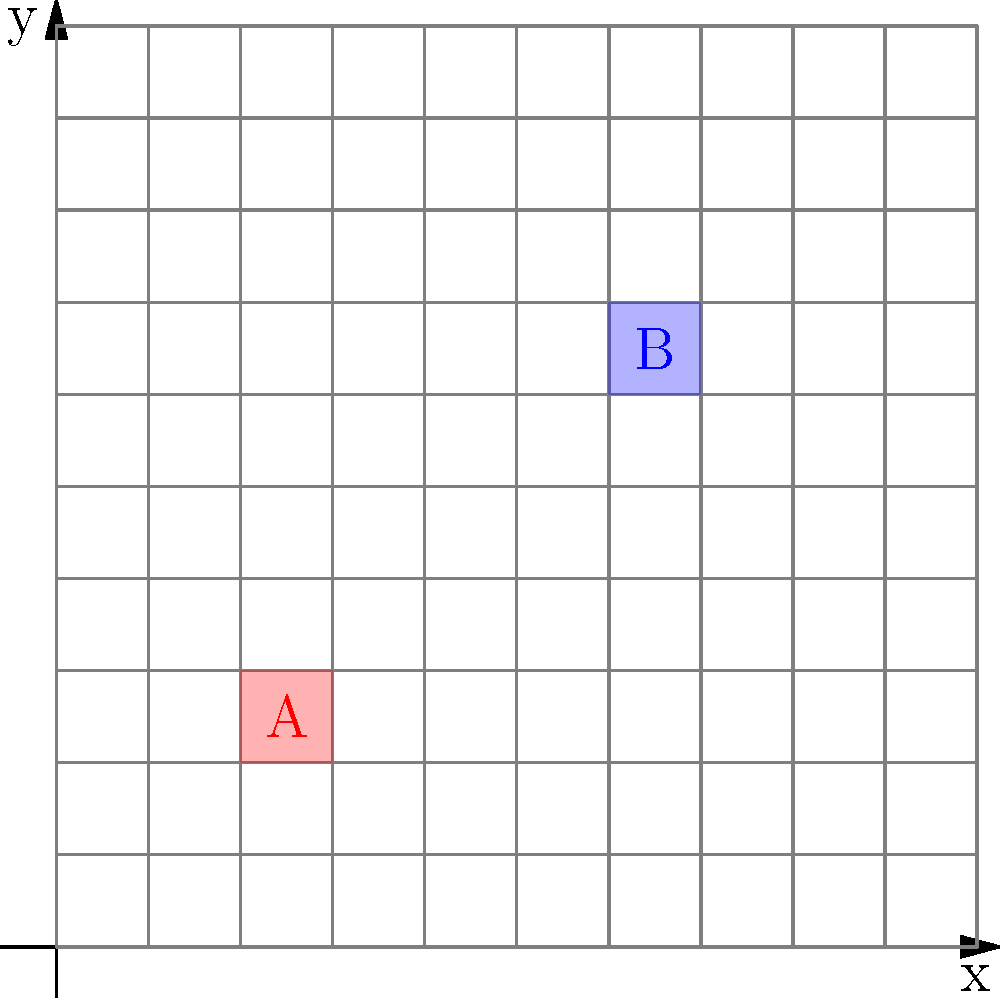In a medical imaging system, a grid pattern is used to assess spatial resolution. The image shows two highlighted squares, A and B, on the grid. If each grid square represents 1 mm, and the smallest discernible feature size is represented by square A, what is the spatial resolution of this imaging system in line pairs per millimeter (lp/mm)? To determine the spatial resolution in line pairs per millimeter (lp/mm), we need to follow these steps:

1. Identify the size of the smallest discernible feature (square A):
   - Each grid square represents 1 mm
   - Square A occupies one grid square
   - Therefore, the smallest discernible feature is 1 mm

2. Calculate the spatial frequency:
   - One line pair consists of one dark line and one light line
   - The width of one line pair is twice the width of the smallest discernible feature
   - Width of one line pair = $2 \times 1$ mm $= 2$ mm

3. Convert to line pairs per millimeter:
   - Spatial resolution (lp/mm) = $\frac{1}{\text{width of one line pair (mm)}}$
   - Spatial resolution = $\frac{1}{2}$ lp/mm $= 0.5$ lp/mm

Therefore, the spatial resolution of this imaging system is 0.5 lp/mm.
Answer: 0.5 lp/mm 